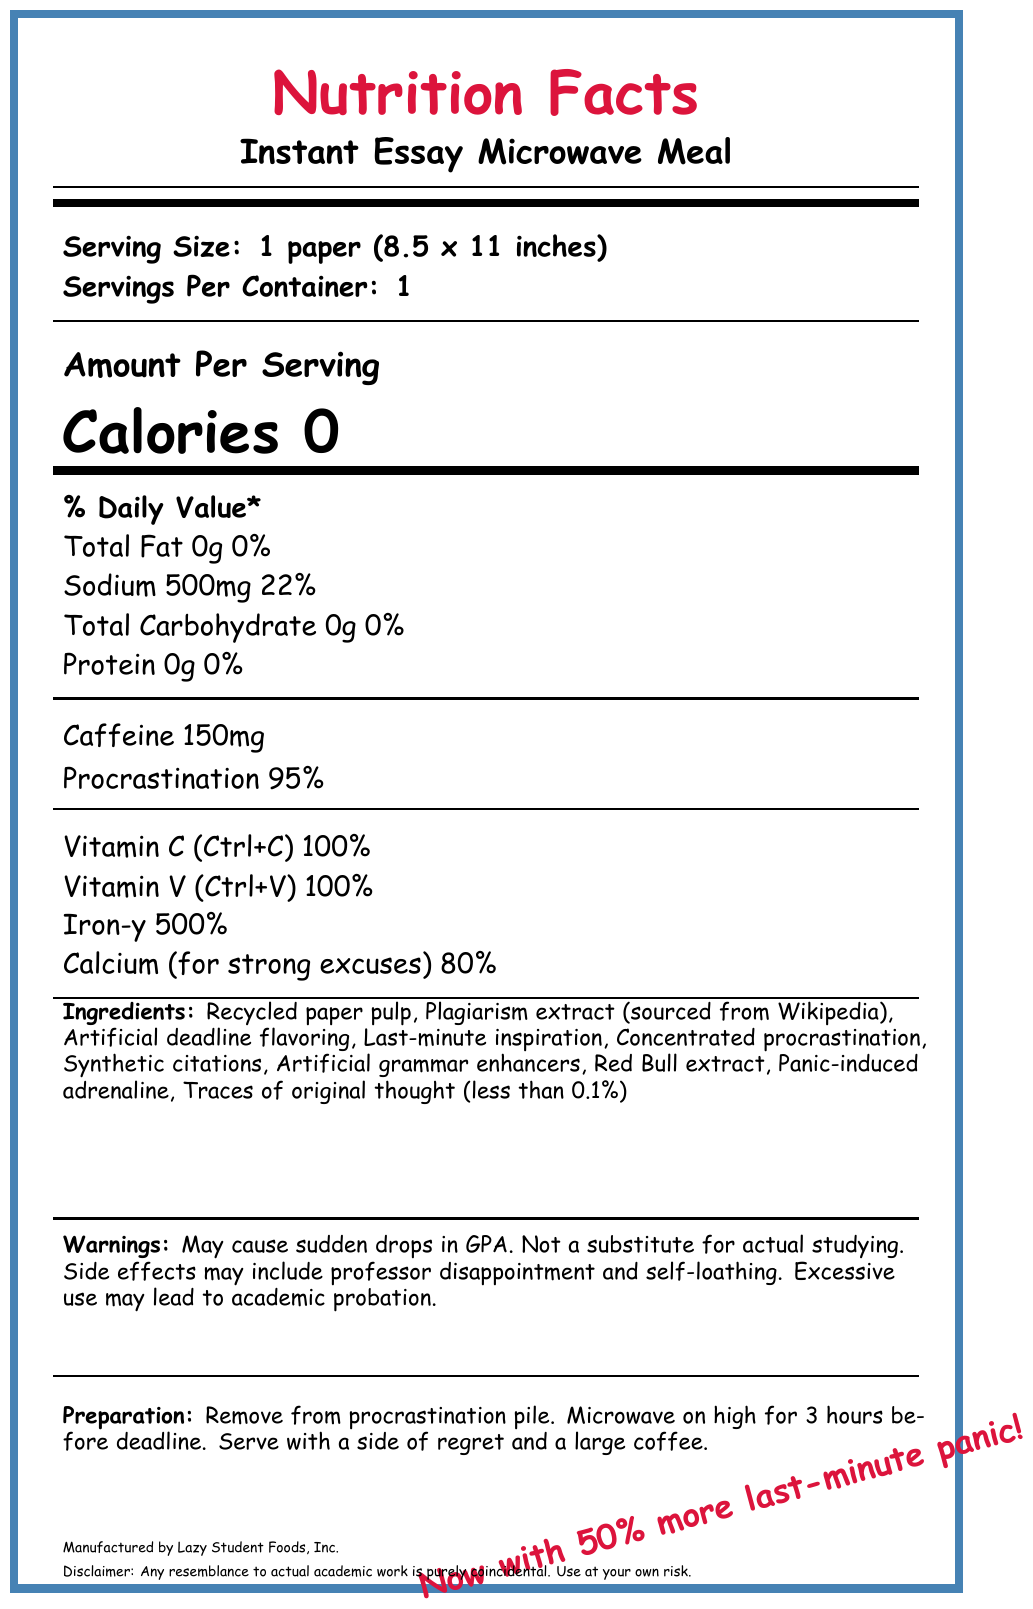what is the serving size? The serving size is listed at the top of the document as "Serving Size: 1 paper (8.5 x 11 inches)".
Answer: 1 paper (8.5 x 11 inches) how many servings are there per container? The document states "Servings Per Container: 1".
Answer: 1 what is the main source of caffeine listed? In the ingredients list, Red Bull extract is mentioned, which is known to contain caffeine.
Answer: Red Bull extract what is the percentage daily value of sodium per serving? The daily value percentage of sodium is written as "Sodium 500mg \hfill 22%".
Answer: 22% which vitamin is included for strong excuses? A. Vitamin A B. Vitamin B C. Calcium D. Vitamin C The document lists "Calcium (for strong excuses) \hfill 80%".
Answer: C. Calcium what is the sarcasm content mentioned on the label? The sarcasm content is highlighted in red text at the bottom of the document as "Now with 50% more last-minute panic!".
Answer: Now with 50% more last-minute panic! what is the potential side effect of this product related to GPA? The warnings section states "May cause sudden drops in GPA".
Answer: May cause sudden drops in GPA how long should you microwave the meal according to the preparation instructions? The preparation instructions say to "Microwave on high for 3 hours before deadline".
Answer: 3 hours before deadline does this meal contain protein? The amount of protein is listed as "Protein 0g \hfill 0%" which indicates there is no protein.
Answer: No what is the leading ingredient in this product? The first ingredient listed is "Recycled paper pulp".
Answer: Recycled paper pulp what is the potential effect on academic status due to excessive use? A. Graduation B. Academic probation C. Free tuition D. Scholarship The warnings section states "Excessive use may lead to academic probation".
Answer: B. Academic probation what is the main flavor enhancer in the meal? A. Garlic B. Artificial deadline flavoring C. Cilantro D. MSG The ingredient "Artificial deadline flavoring" is mentioned in the list.
Answer: B. Artificial deadline flavoring summarize the entire document The document humorously mimics a nutrition label, describing a fictional ready-made essay filled with components related to procrastination and last-minute effort, while warning about academic consequences.
Answer: The document is a sarcastic nutrition facts label for an "Instant Essay Microwave Meal." It details the serving size, contents, vitamins, minerals, and ingredients, which humorously include items like "Plagiarism extract" and "Last-minute inspiration." It also provides warnings related to academic performance and includes amusing preparation instructions. what is the total carbohydrate content per serving? The total carbohydrate content per serving is listed as "Total Carbohydrate 0g".
Answer: 0g are there any traces of originality in this product? The ingredients list mentions "Traces of original thought (less than 0.1%)".
Answer: Yes is this product recommended for actual studying? The warnings clearly state "Not a substitute for actual studying".
Answer: No where is the plagiarism extract sourced from? The ingredient list specifies "Plagiarism extract (sourced from Wikipedia)".
Answer: Wikipedia who is the manufacturer of this product? The manufacturer is listed at the bottom of the document as "Manufactured by Lazy Student Foods, Inc."
Answer: Lazy Student Foods, Inc. what is the exact percentage of procrastination in the product? The document says "Procrastination 95%" under the nutritional section.
Answer: 95% how do you interpret the "Iron-y" percentage? The vitamins and minerals section lists "Iron-y \hfill 500%," indicating a high presence of irony in a humorous context.
Answer: 500% what is the exact caffeine content in each serving? The nutritional section specifies "Caffeine 150mg."
Answer: 150mg what font is used in the main document? The document does not provide any information about the font used.
Answer: Cannot be determined 